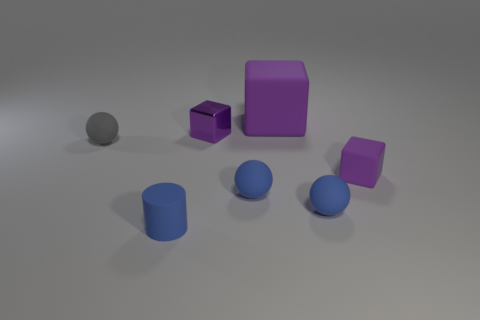Subtract all big matte blocks. How many blocks are left? 2 Add 1 small brown things. How many objects exist? 8 Add 5 big green metallic spheres. How many big green metallic spheres exist? 5 Subtract all blue balls. How many balls are left? 1 Subtract 0 gray cylinders. How many objects are left? 7 Subtract all cubes. How many objects are left? 4 Subtract all blue spheres. Subtract all yellow cylinders. How many spheres are left? 1 Subtract all brown cylinders. How many gray spheres are left? 1 Subtract all tiny gray rubber spheres. Subtract all gray balls. How many objects are left? 5 Add 1 tiny gray rubber balls. How many tiny gray rubber balls are left? 2 